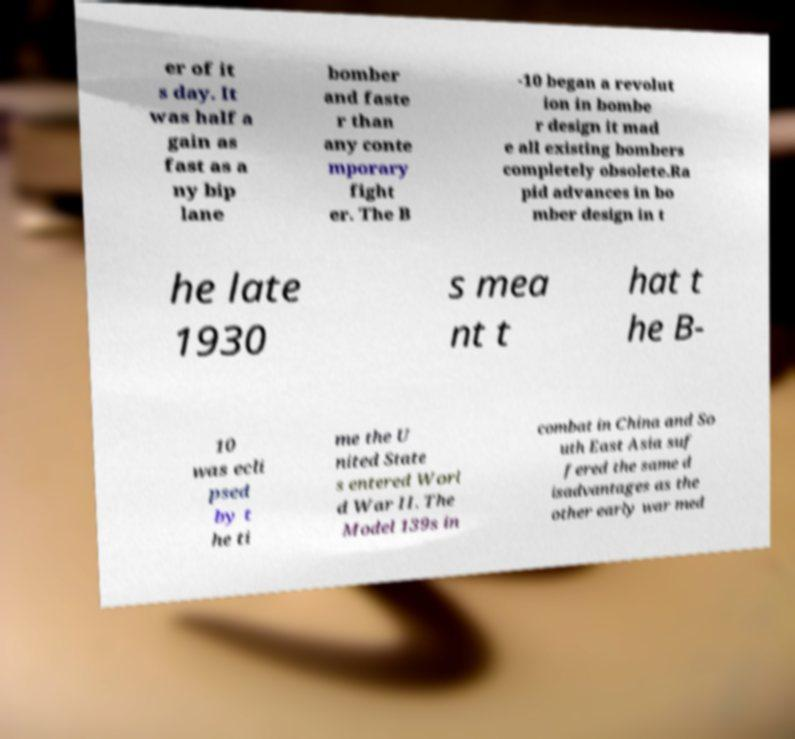For documentation purposes, I need the text within this image transcribed. Could you provide that? er of it s day. It was half a gain as fast as a ny bip lane bomber and faste r than any conte mporary fight er. The B -10 began a revolut ion in bombe r design it mad e all existing bombers completely obsolete.Ra pid advances in bo mber design in t he late 1930 s mea nt t hat t he B- 10 was ecli psed by t he ti me the U nited State s entered Worl d War II. The Model 139s in combat in China and So uth East Asia suf fered the same d isadvantages as the other early war med 